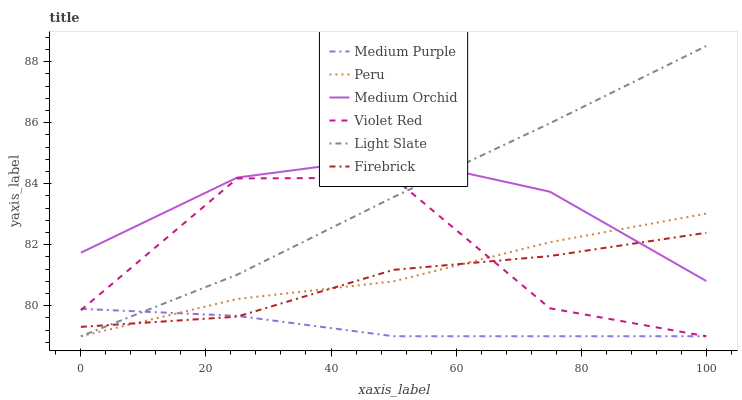Does Medium Purple have the minimum area under the curve?
Answer yes or no. Yes. Does Light Slate have the maximum area under the curve?
Answer yes or no. Yes. Does Firebrick have the minimum area under the curve?
Answer yes or no. No. Does Firebrick have the maximum area under the curve?
Answer yes or no. No. Is Light Slate the smoothest?
Answer yes or no. Yes. Is Violet Red the roughest?
Answer yes or no. Yes. Is Firebrick the smoothest?
Answer yes or no. No. Is Firebrick the roughest?
Answer yes or no. No. Does Violet Red have the lowest value?
Answer yes or no. Yes. Does Firebrick have the lowest value?
Answer yes or no. No. Does Light Slate have the highest value?
Answer yes or no. Yes. Does Firebrick have the highest value?
Answer yes or no. No. Is Medium Purple less than Medium Orchid?
Answer yes or no. Yes. Is Medium Orchid greater than Violet Red?
Answer yes or no. Yes. Does Peru intersect Medium Orchid?
Answer yes or no. Yes. Is Peru less than Medium Orchid?
Answer yes or no. No. Is Peru greater than Medium Orchid?
Answer yes or no. No. Does Medium Purple intersect Medium Orchid?
Answer yes or no. No. 